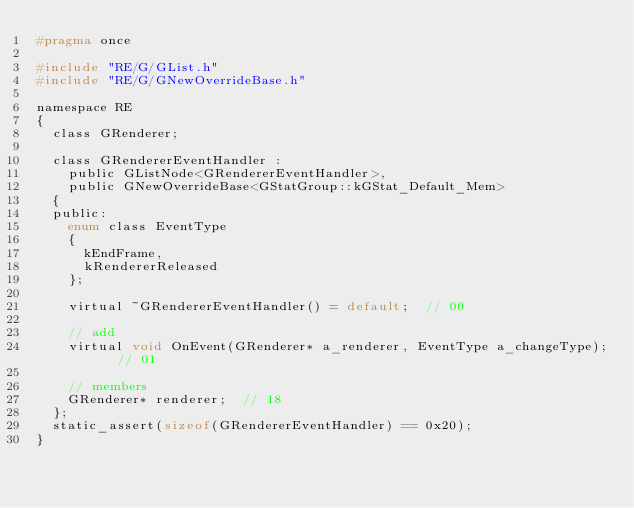<code> <loc_0><loc_0><loc_500><loc_500><_C_>#pragma once

#include "RE/G/GList.h"
#include "RE/G/GNewOverrideBase.h"

namespace RE
{
	class GRenderer;

	class GRendererEventHandler :
		public GListNode<GRendererEventHandler>,
		public GNewOverrideBase<GStatGroup::kGStat_Default_Mem>
	{
	public:
		enum class EventType
		{
			kEndFrame,
			kRendererReleased
		};

		virtual ~GRendererEventHandler() = default;	 // 00

		// add
		virtual void OnEvent(GRenderer* a_renderer, EventType a_changeType);  // 01

		// members
		GRenderer* renderer;  // 18
	};
	static_assert(sizeof(GRendererEventHandler) == 0x20);
}
</code> 